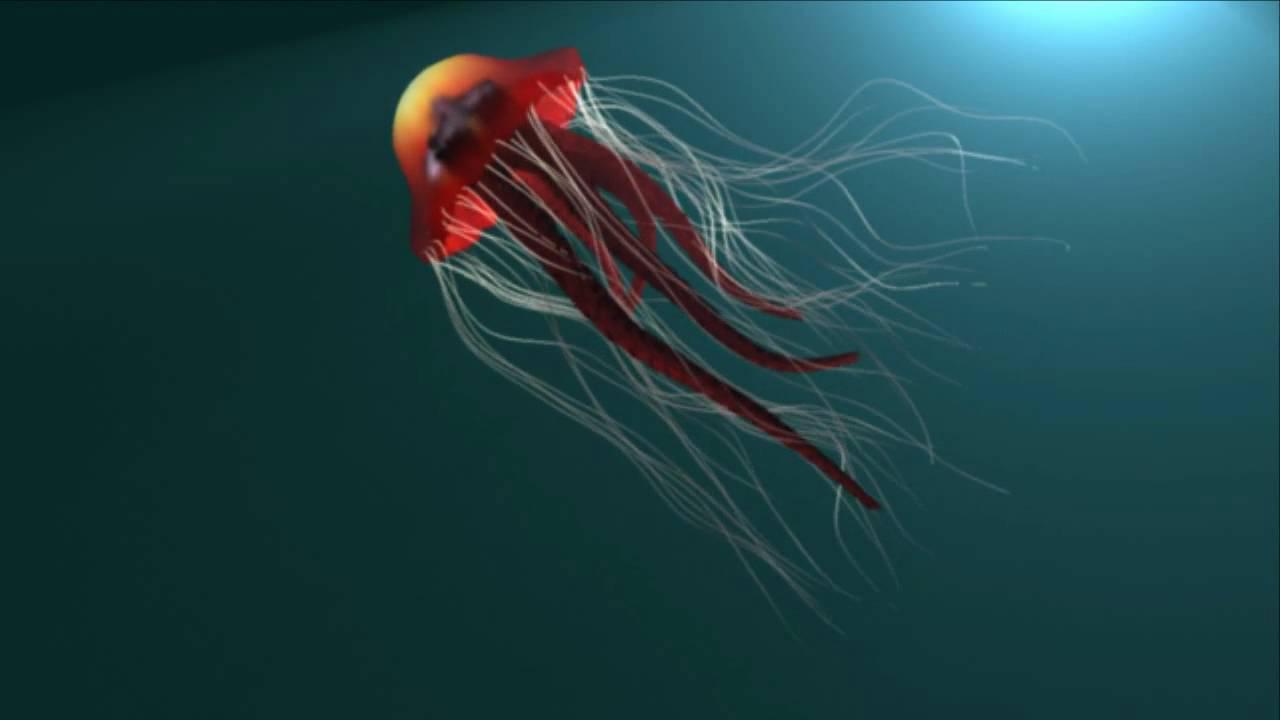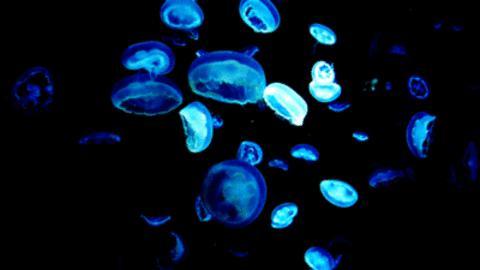The first image is the image on the left, the second image is the image on the right. Assess this claim about the two images: "There are less than 9 jellyfish.". Correct or not? Answer yes or no. No. The first image is the image on the left, the second image is the image on the right. For the images shown, is this caption "One image features a translucent blue jellyfish moving diagonally to the right, with tentacles trailing behind it." true? Answer yes or no. No. 